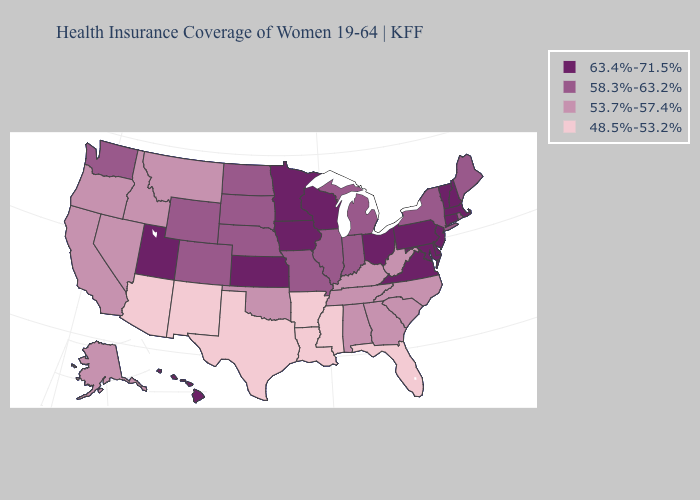Among the states that border Ohio , does Pennsylvania have the highest value?
Concise answer only. Yes. What is the value of Nebraska?
Short answer required. 58.3%-63.2%. Does North Dakota have the lowest value in the MidWest?
Be succinct. Yes. Name the states that have a value in the range 53.7%-57.4%?
Concise answer only. Alabama, Alaska, California, Georgia, Idaho, Kentucky, Montana, Nevada, North Carolina, Oklahoma, Oregon, South Carolina, Tennessee, West Virginia. Does the map have missing data?
Write a very short answer. No. What is the value of Montana?
Be succinct. 53.7%-57.4%. What is the lowest value in states that border North Carolina?
Quick response, please. 53.7%-57.4%. Name the states that have a value in the range 63.4%-71.5%?
Short answer required. Connecticut, Delaware, Hawaii, Iowa, Kansas, Maryland, Massachusetts, Minnesota, New Hampshire, New Jersey, Ohio, Pennsylvania, Utah, Vermont, Virginia, Wisconsin. What is the highest value in states that border Connecticut?
Answer briefly. 63.4%-71.5%. What is the lowest value in the MidWest?
Write a very short answer. 58.3%-63.2%. Among the states that border New Jersey , does Delaware have the highest value?
Answer briefly. Yes. Name the states that have a value in the range 53.7%-57.4%?
Short answer required. Alabama, Alaska, California, Georgia, Idaho, Kentucky, Montana, Nevada, North Carolina, Oklahoma, Oregon, South Carolina, Tennessee, West Virginia. What is the value of Hawaii?
Be succinct. 63.4%-71.5%. What is the value of Arkansas?
Quick response, please. 48.5%-53.2%. Which states have the highest value in the USA?
Keep it brief. Connecticut, Delaware, Hawaii, Iowa, Kansas, Maryland, Massachusetts, Minnesota, New Hampshire, New Jersey, Ohio, Pennsylvania, Utah, Vermont, Virginia, Wisconsin. 